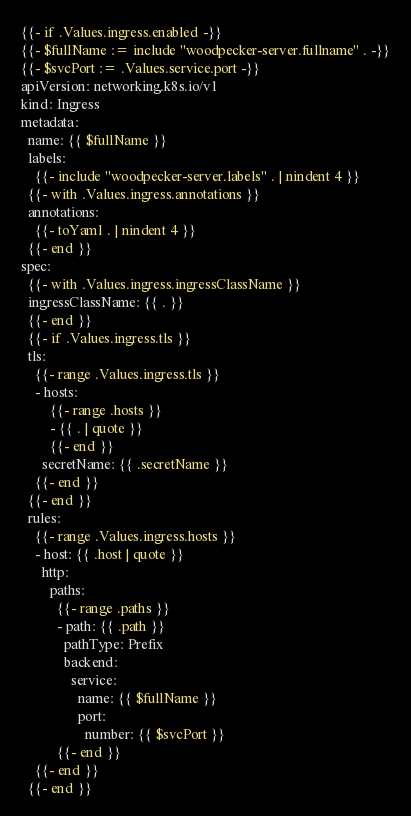<code> <loc_0><loc_0><loc_500><loc_500><_YAML_>{{- if .Values.ingress.enabled -}}
{{- $fullName := include "woodpecker-server.fullname" . -}}
{{- $svcPort := .Values.service.port -}}
apiVersion: networking.k8s.io/v1
kind: Ingress
metadata:
  name: {{ $fullName }}
  labels:
    {{- include "woodpecker-server.labels" . | nindent 4 }}
  {{- with .Values.ingress.annotations }}
  annotations:
    {{- toYaml . | nindent 4 }}
  {{- end }}
spec:
  {{- with .Values.ingress.ingressClassName }}
  ingressClassName: {{ . }}
  {{- end }}
  {{- if .Values.ingress.tls }}
  tls:
    {{- range .Values.ingress.tls }}
    - hosts:
        {{- range .hosts }}
        - {{ . | quote }}
        {{- end }}
      secretName: {{ .secretName }}
    {{- end }}
  {{- end }}
  rules:
    {{- range .Values.ingress.hosts }}
    - host: {{ .host | quote }}
      http:
        paths:
          {{- range .paths }}
          - path: {{ .path }}
            pathType: Prefix
            backend:
              service:
                name: {{ $fullName }}
                port:
                  number: {{ $svcPort }}
          {{- end }}
    {{- end }}
  {{- end }}
</code> 